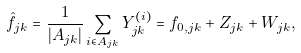<formula> <loc_0><loc_0><loc_500><loc_500>\hat { f } _ { j k } = \frac { 1 } { | A _ { j k } | } \sum _ { i \in A _ { j k } } Y _ { j k } ^ { ( i ) } = f _ { 0 , j k } + Z _ { j k } + W _ { j k } ,</formula> 